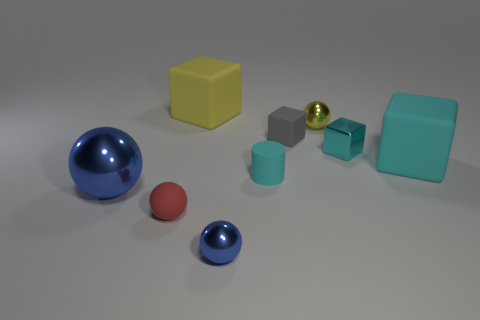Subtract all tiny cyan cubes. How many cubes are left? 3 Subtract all red balls. How many cyan cubes are left? 2 Subtract 1 spheres. How many spheres are left? 3 Add 1 gray matte balls. How many objects exist? 10 Subtract all yellow cubes. How many cubes are left? 3 Subtract all cubes. How many objects are left? 5 Subtract all brown cubes. Subtract all cyan spheres. How many cubes are left? 4 Add 7 blue shiny spheres. How many blue shiny spheres exist? 9 Subtract 0 blue cylinders. How many objects are left? 9 Subtract all small green metal things. Subtract all big yellow rubber things. How many objects are left? 8 